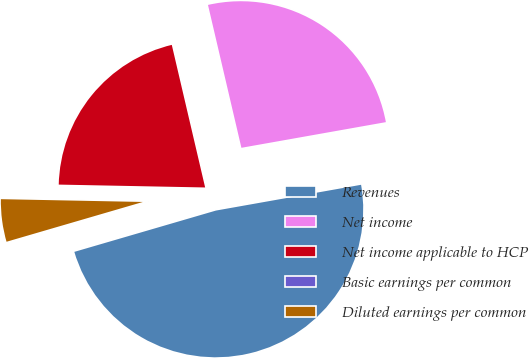Convert chart to OTSL. <chart><loc_0><loc_0><loc_500><loc_500><pie_chart><fcel>Revenues<fcel>Net income<fcel>Net income applicable to HCP<fcel>Basic earnings per common<fcel>Diluted earnings per common<nl><fcel>48.28%<fcel>25.86%<fcel>21.03%<fcel>0.0%<fcel>4.83%<nl></chart> 